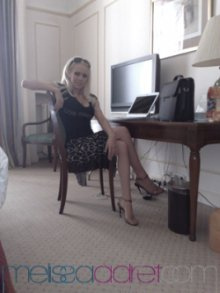Extract all visible text content from this image. meissaadretcom 